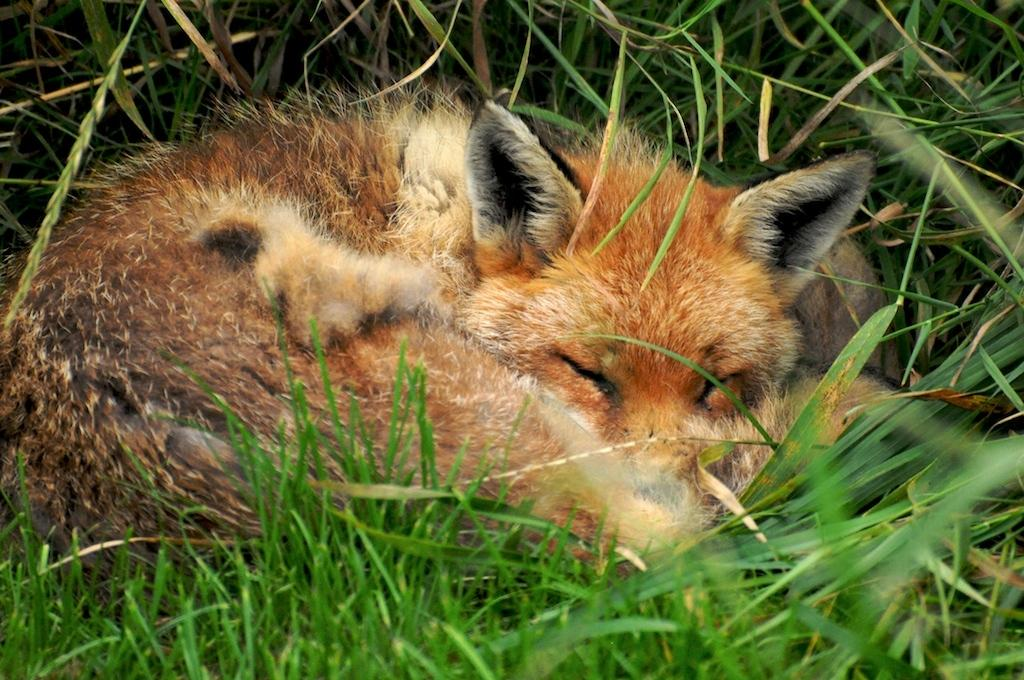What type of animal is in the image? There is a swift fox in the image. What is the swift fox doing in the image? The swift fox is sleeping in the grass. What can be seen behind the swift fox? There is grass visible behind the fox. How many sisters are present in the image? There are no sisters present in the image; it features a swift fox sleeping in the grass. What type of soup is being served in the image? There is no soup present in the image; it features a swift fox sleeping in the grass. 